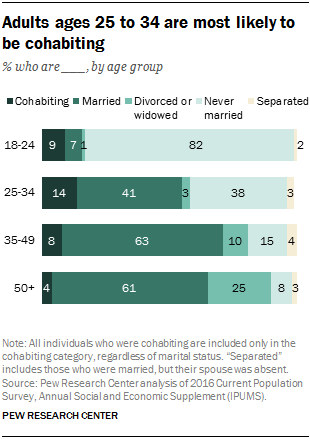Draw attention to some important aspects in this diagram. The difference between the highest dark green and lowest light green value is 55. There are five colors in the bar. 